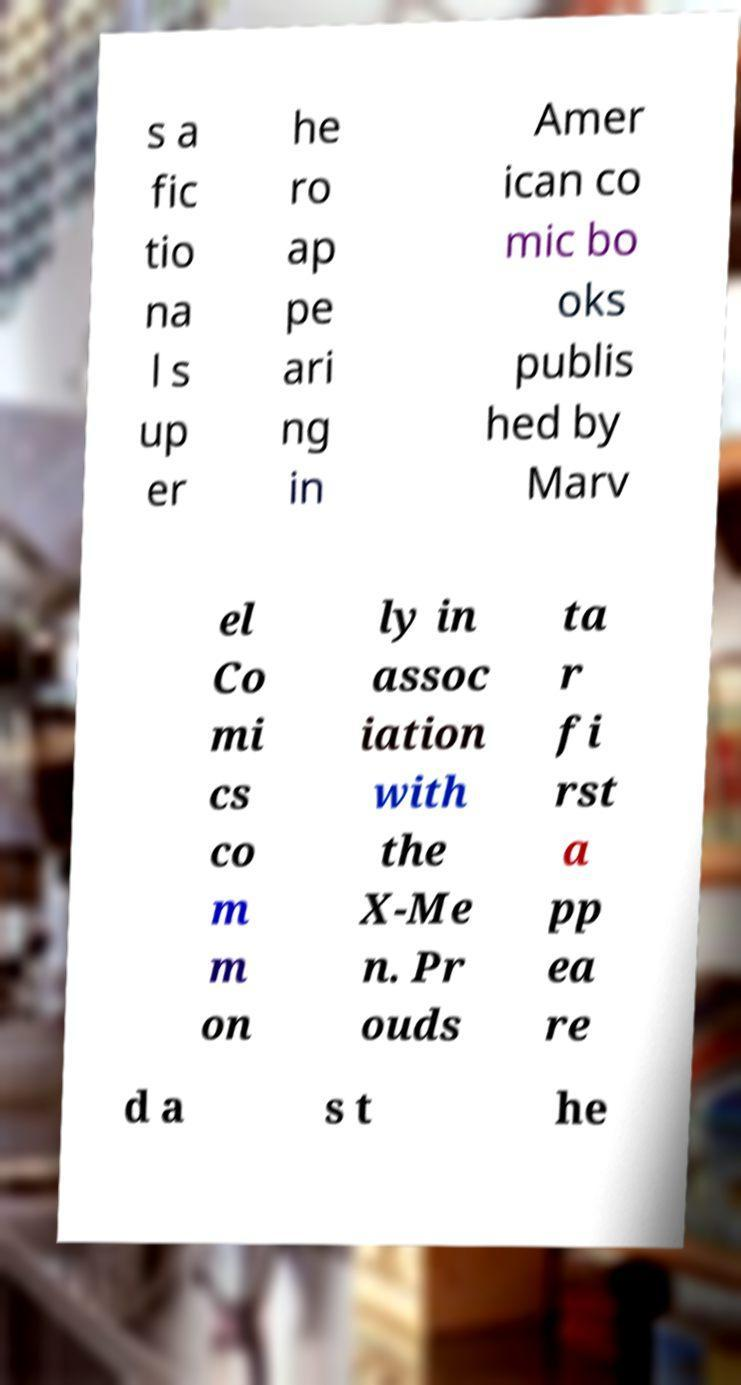Can you accurately transcribe the text from the provided image for me? s a fic tio na l s up er he ro ap pe ari ng in Amer ican co mic bo oks publis hed by Marv el Co mi cs co m m on ly in assoc iation with the X-Me n. Pr ouds ta r fi rst a pp ea re d a s t he 